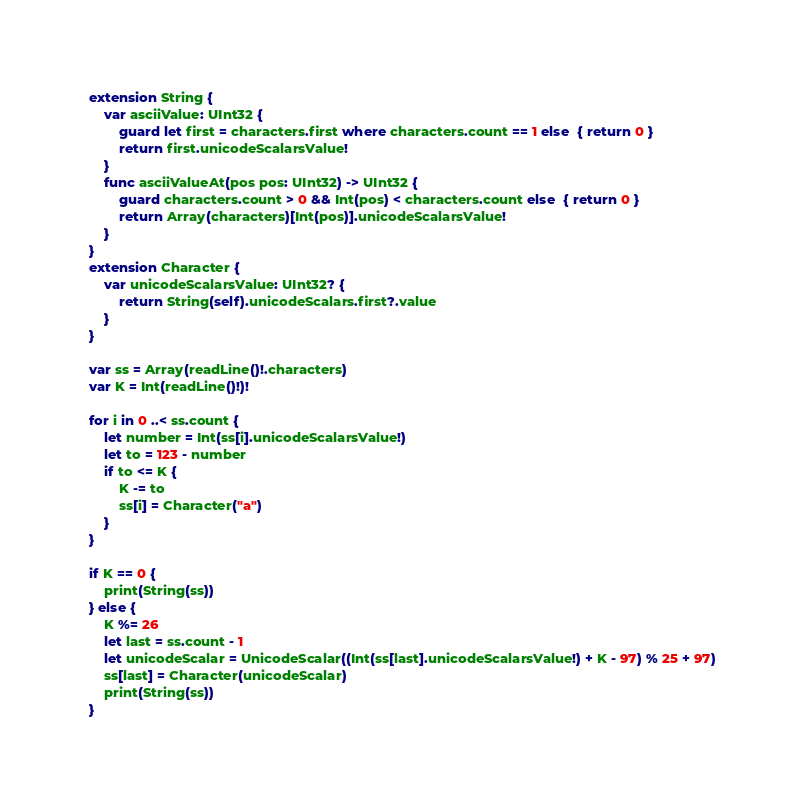Convert code to text. <code><loc_0><loc_0><loc_500><loc_500><_Swift_>extension String {
    var asciiValue: UInt32 {
        guard let first = characters.first where characters.count == 1 else  { return 0 }
        return first.unicodeScalarsValue!
    }
    func asciiValueAt(pos pos: UInt32) -> UInt32 {
        guard characters.count > 0 && Int(pos) < characters.count else  { return 0 }
        return Array(characters)[Int(pos)].unicodeScalarsValue!
    }
}
extension Character {
    var unicodeScalarsValue: UInt32? {
        return String(self).unicodeScalars.first?.value
    }
}

var ss = Array(readLine()!.characters)
var K = Int(readLine()!)!

for i in 0 ..< ss.count {
    let number = Int(ss[i].unicodeScalarsValue!)
    let to = 123 - number
    if to <= K {
        K -= to
        ss[i] = Character("a")
    }
}

if K == 0 {
    print(String(ss))
} else {
    K %= 26
    let last = ss.count - 1
    let unicodeScalar = UnicodeScalar((Int(ss[last].unicodeScalarsValue!) + K - 97) % 25 + 97)
    ss[last] = Character(unicodeScalar)
    print(String(ss))
}
</code> 